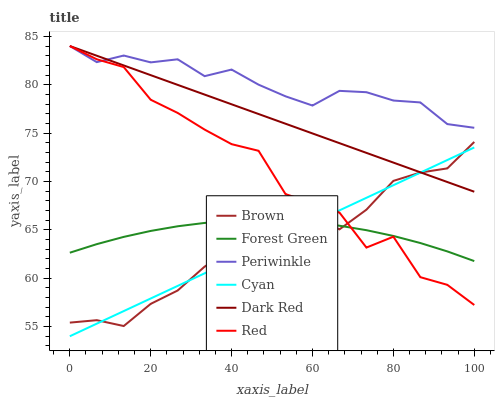Does Brown have the minimum area under the curve?
Answer yes or no. Yes. Does Periwinkle have the maximum area under the curve?
Answer yes or no. Yes. Does Dark Red have the minimum area under the curve?
Answer yes or no. No. Does Dark Red have the maximum area under the curve?
Answer yes or no. No. Is Cyan the smoothest?
Answer yes or no. Yes. Is Red the roughest?
Answer yes or no. Yes. Is Dark Red the smoothest?
Answer yes or no. No. Is Dark Red the roughest?
Answer yes or no. No. Does Cyan have the lowest value?
Answer yes or no. Yes. Does Dark Red have the lowest value?
Answer yes or no. No. Does Red have the highest value?
Answer yes or no. Yes. Does Forest Green have the highest value?
Answer yes or no. No. Is Cyan less than Periwinkle?
Answer yes or no. Yes. Is Periwinkle greater than Brown?
Answer yes or no. Yes. Does Dark Red intersect Brown?
Answer yes or no. Yes. Is Dark Red less than Brown?
Answer yes or no. No. Is Dark Red greater than Brown?
Answer yes or no. No. Does Cyan intersect Periwinkle?
Answer yes or no. No. 